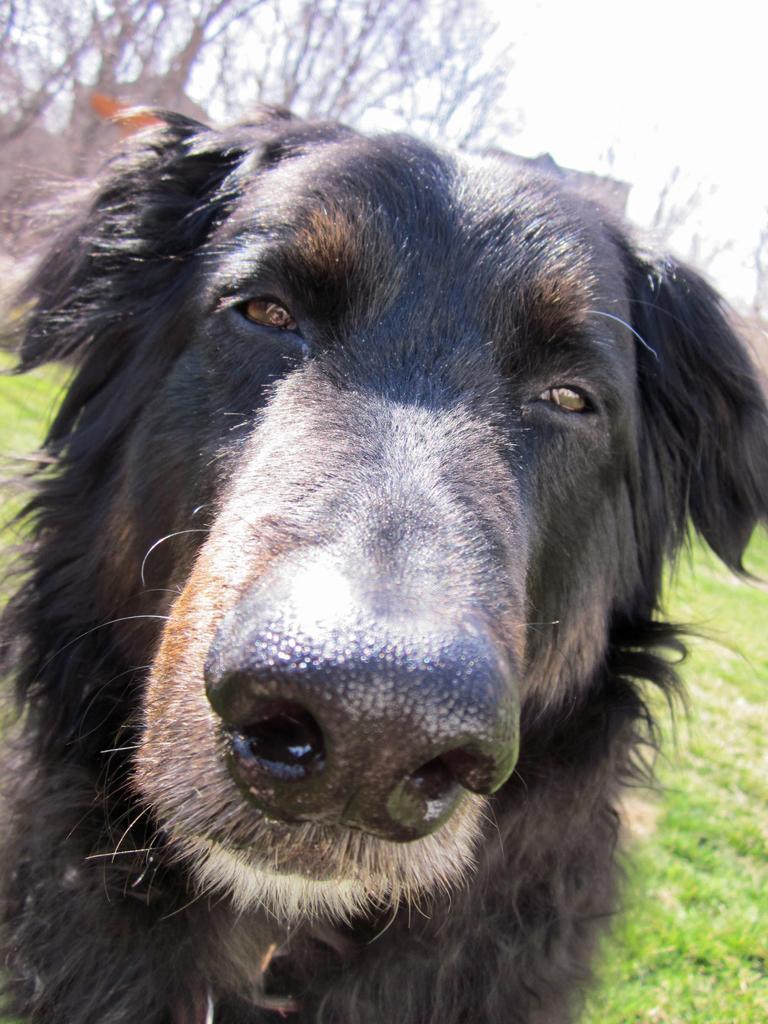Please provide a concise description of this image. This image is taken outdoors. In the background there are two houses and there are a few trees. At the bottom of the image there is a ground with grass on it. In the middle of the image there is a dog which is black in color. 